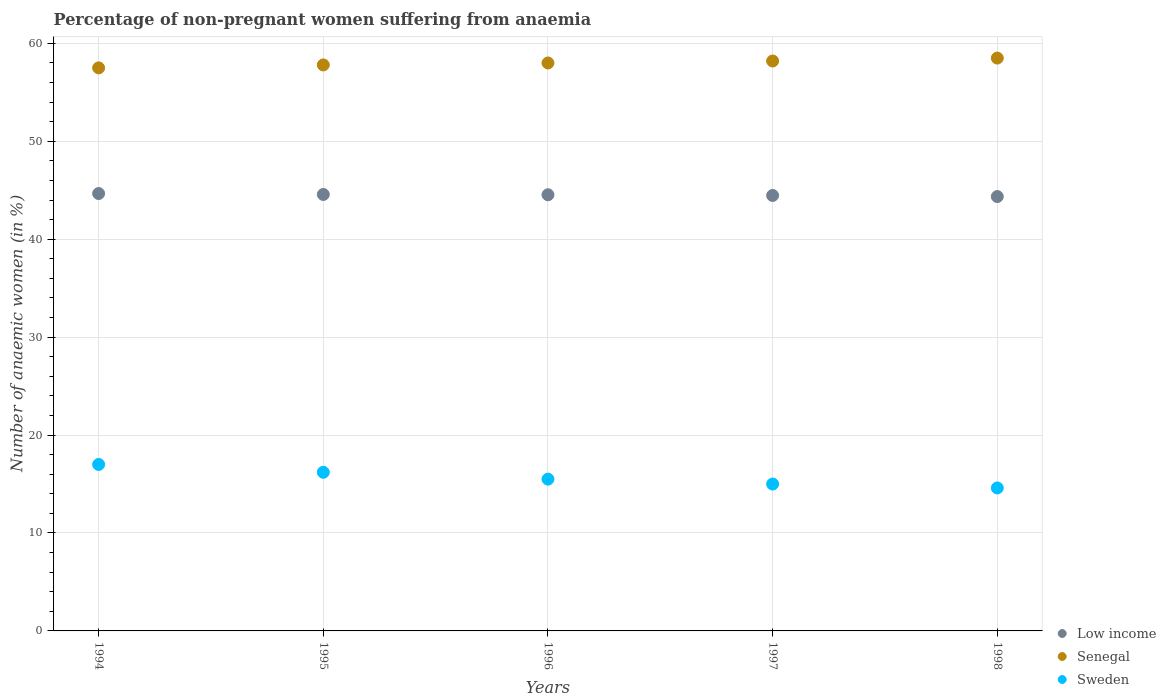How many different coloured dotlines are there?
Your response must be concise. 3. Is the number of dotlines equal to the number of legend labels?
Provide a succinct answer. Yes. What is the percentage of non-pregnant women suffering from anaemia in Low income in 1994?
Keep it short and to the point. 44.67. Across all years, what is the maximum percentage of non-pregnant women suffering from anaemia in Sweden?
Offer a terse response. 17. Across all years, what is the minimum percentage of non-pregnant women suffering from anaemia in Senegal?
Your answer should be very brief. 57.5. In which year was the percentage of non-pregnant women suffering from anaemia in Senegal maximum?
Your answer should be very brief. 1998. What is the total percentage of non-pregnant women suffering from anaemia in Sweden in the graph?
Provide a short and direct response. 78.3. What is the difference between the percentage of non-pregnant women suffering from anaemia in Sweden in 1995 and that in 1996?
Offer a very short reply. 0.7. What is the difference between the percentage of non-pregnant women suffering from anaemia in Senegal in 1994 and the percentage of non-pregnant women suffering from anaemia in Sweden in 1997?
Your answer should be very brief. 42.5. What is the average percentage of non-pregnant women suffering from anaemia in Senegal per year?
Give a very brief answer. 58. In the year 1998, what is the difference between the percentage of non-pregnant women suffering from anaemia in Low income and percentage of non-pregnant women suffering from anaemia in Sweden?
Provide a succinct answer. 29.76. What is the ratio of the percentage of non-pregnant women suffering from anaemia in Sweden in 1995 to that in 1998?
Your answer should be very brief. 1.11. Is the percentage of non-pregnant women suffering from anaemia in Sweden in 1996 less than that in 1997?
Provide a short and direct response. No. Is the difference between the percentage of non-pregnant women suffering from anaemia in Low income in 1994 and 1998 greater than the difference between the percentage of non-pregnant women suffering from anaemia in Sweden in 1994 and 1998?
Offer a terse response. No. What is the difference between the highest and the second highest percentage of non-pregnant women suffering from anaemia in Sweden?
Keep it short and to the point. 0.8. What is the difference between the highest and the lowest percentage of non-pregnant women suffering from anaemia in Low income?
Offer a terse response. 0.31. Is the sum of the percentage of non-pregnant women suffering from anaemia in Sweden in 1994 and 1996 greater than the maximum percentage of non-pregnant women suffering from anaemia in Senegal across all years?
Offer a terse response. No. Is the percentage of non-pregnant women suffering from anaemia in Low income strictly greater than the percentage of non-pregnant women suffering from anaemia in Sweden over the years?
Provide a short and direct response. Yes. Is the percentage of non-pregnant women suffering from anaemia in Senegal strictly less than the percentage of non-pregnant women suffering from anaemia in Sweden over the years?
Make the answer very short. No. How many dotlines are there?
Give a very brief answer. 3. How many years are there in the graph?
Ensure brevity in your answer.  5. What is the difference between two consecutive major ticks on the Y-axis?
Make the answer very short. 10. Where does the legend appear in the graph?
Keep it short and to the point. Bottom right. How are the legend labels stacked?
Give a very brief answer. Vertical. What is the title of the graph?
Give a very brief answer. Percentage of non-pregnant women suffering from anaemia. Does "Netherlands" appear as one of the legend labels in the graph?
Offer a terse response. No. What is the label or title of the X-axis?
Your response must be concise. Years. What is the label or title of the Y-axis?
Keep it short and to the point. Number of anaemic women (in %). What is the Number of anaemic women (in %) of Low income in 1994?
Provide a succinct answer. 44.67. What is the Number of anaemic women (in %) in Senegal in 1994?
Give a very brief answer. 57.5. What is the Number of anaemic women (in %) of Sweden in 1994?
Provide a succinct answer. 17. What is the Number of anaemic women (in %) of Low income in 1995?
Offer a very short reply. 44.57. What is the Number of anaemic women (in %) of Senegal in 1995?
Provide a succinct answer. 57.8. What is the Number of anaemic women (in %) of Low income in 1996?
Make the answer very short. 44.54. What is the Number of anaemic women (in %) in Sweden in 1996?
Provide a short and direct response. 15.5. What is the Number of anaemic women (in %) of Low income in 1997?
Your answer should be very brief. 44.47. What is the Number of anaemic women (in %) in Senegal in 1997?
Keep it short and to the point. 58.2. What is the Number of anaemic women (in %) of Sweden in 1997?
Provide a short and direct response. 15. What is the Number of anaemic women (in %) of Low income in 1998?
Provide a short and direct response. 44.36. What is the Number of anaemic women (in %) in Senegal in 1998?
Give a very brief answer. 58.5. What is the Number of anaemic women (in %) of Sweden in 1998?
Give a very brief answer. 14.6. Across all years, what is the maximum Number of anaemic women (in %) of Low income?
Your answer should be very brief. 44.67. Across all years, what is the maximum Number of anaemic women (in %) of Senegal?
Provide a short and direct response. 58.5. Across all years, what is the minimum Number of anaemic women (in %) in Low income?
Your response must be concise. 44.36. Across all years, what is the minimum Number of anaemic women (in %) of Senegal?
Keep it short and to the point. 57.5. Across all years, what is the minimum Number of anaemic women (in %) in Sweden?
Your answer should be very brief. 14.6. What is the total Number of anaemic women (in %) of Low income in the graph?
Make the answer very short. 222.61. What is the total Number of anaemic women (in %) in Senegal in the graph?
Offer a terse response. 290. What is the total Number of anaemic women (in %) in Sweden in the graph?
Your answer should be very brief. 78.3. What is the difference between the Number of anaemic women (in %) in Low income in 1994 and that in 1995?
Offer a terse response. 0.1. What is the difference between the Number of anaemic women (in %) of Low income in 1994 and that in 1996?
Give a very brief answer. 0.12. What is the difference between the Number of anaemic women (in %) in Senegal in 1994 and that in 1996?
Your answer should be very brief. -0.5. What is the difference between the Number of anaemic women (in %) of Sweden in 1994 and that in 1996?
Ensure brevity in your answer.  1.5. What is the difference between the Number of anaemic women (in %) of Low income in 1994 and that in 1997?
Your answer should be compact. 0.2. What is the difference between the Number of anaemic women (in %) in Sweden in 1994 and that in 1997?
Your answer should be compact. 2. What is the difference between the Number of anaemic women (in %) in Low income in 1994 and that in 1998?
Ensure brevity in your answer.  0.31. What is the difference between the Number of anaemic women (in %) of Sweden in 1994 and that in 1998?
Provide a short and direct response. 2.4. What is the difference between the Number of anaemic women (in %) in Low income in 1995 and that in 1996?
Offer a very short reply. 0.03. What is the difference between the Number of anaemic women (in %) of Low income in 1995 and that in 1997?
Offer a very short reply. 0.1. What is the difference between the Number of anaemic women (in %) in Senegal in 1995 and that in 1997?
Your answer should be very brief. -0.4. What is the difference between the Number of anaemic women (in %) in Low income in 1995 and that in 1998?
Your answer should be compact. 0.21. What is the difference between the Number of anaemic women (in %) of Senegal in 1995 and that in 1998?
Your answer should be compact. -0.7. What is the difference between the Number of anaemic women (in %) of Sweden in 1995 and that in 1998?
Make the answer very short. 1.6. What is the difference between the Number of anaemic women (in %) of Low income in 1996 and that in 1997?
Ensure brevity in your answer.  0.07. What is the difference between the Number of anaemic women (in %) in Senegal in 1996 and that in 1997?
Keep it short and to the point. -0.2. What is the difference between the Number of anaemic women (in %) of Sweden in 1996 and that in 1997?
Provide a succinct answer. 0.5. What is the difference between the Number of anaemic women (in %) of Low income in 1996 and that in 1998?
Give a very brief answer. 0.18. What is the difference between the Number of anaemic women (in %) of Senegal in 1996 and that in 1998?
Make the answer very short. -0.5. What is the difference between the Number of anaemic women (in %) in Low income in 1997 and that in 1998?
Give a very brief answer. 0.11. What is the difference between the Number of anaemic women (in %) in Senegal in 1997 and that in 1998?
Provide a short and direct response. -0.3. What is the difference between the Number of anaemic women (in %) of Sweden in 1997 and that in 1998?
Give a very brief answer. 0.4. What is the difference between the Number of anaemic women (in %) in Low income in 1994 and the Number of anaemic women (in %) in Senegal in 1995?
Offer a very short reply. -13.13. What is the difference between the Number of anaemic women (in %) in Low income in 1994 and the Number of anaemic women (in %) in Sweden in 1995?
Ensure brevity in your answer.  28.47. What is the difference between the Number of anaemic women (in %) of Senegal in 1994 and the Number of anaemic women (in %) of Sweden in 1995?
Your answer should be compact. 41.3. What is the difference between the Number of anaemic women (in %) in Low income in 1994 and the Number of anaemic women (in %) in Senegal in 1996?
Your answer should be compact. -13.33. What is the difference between the Number of anaemic women (in %) of Low income in 1994 and the Number of anaemic women (in %) of Sweden in 1996?
Give a very brief answer. 29.17. What is the difference between the Number of anaemic women (in %) of Low income in 1994 and the Number of anaemic women (in %) of Senegal in 1997?
Provide a succinct answer. -13.53. What is the difference between the Number of anaemic women (in %) of Low income in 1994 and the Number of anaemic women (in %) of Sweden in 1997?
Provide a succinct answer. 29.67. What is the difference between the Number of anaemic women (in %) of Senegal in 1994 and the Number of anaemic women (in %) of Sweden in 1997?
Provide a succinct answer. 42.5. What is the difference between the Number of anaemic women (in %) in Low income in 1994 and the Number of anaemic women (in %) in Senegal in 1998?
Ensure brevity in your answer.  -13.83. What is the difference between the Number of anaemic women (in %) in Low income in 1994 and the Number of anaemic women (in %) in Sweden in 1998?
Offer a very short reply. 30.07. What is the difference between the Number of anaemic women (in %) of Senegal in 1994 and the Number of anaemic women (in %) of Sweden in 1998?
Provide a short and direct response. 42.9. What is the difference between the Number of anaemic women (in %) in Low income in 1995 and the Number of anaemic women (in %) in Senegal in 1996?
Your answer should be compact. -13.43. What is the difference between the Number of anaemic women (in %) in Low income in 1995 and the Number of anaemic women (in %) in Sweden in 1996?
Offer a very short reply. 29.07. What is the difference between the Number of anaemic women (in %) in Senegal in 1995 and the Number of anaemic women (in %) in Sweden in 1996?
Your response must be concise. 42.3. What is the difference between the Number of anaemic women (in %) in Low income in 1995 and the Number of anaemic women (in %) in Senegal in 1997?
Your response must be concise. -13.63. What is the difference between the Number of anaemic women (in %) of Low income in 1995 and the Number of anaemic women (in %) of Sweden in 1997?
Offer a very short reply. 29.57. What is the difference between the Number of anaemic women (in %) of Senegal in 1995 and the Number of anaemic women (in %) of Sweden in 1997?
Ensure brevity in your answer.  42.8. What is the difference between the Number of anaemic women (in %) of Low income in 1995 and the Number of anaemic women (in %) of Senegal in 1998?
Keep it short and to the point. -13.93. What is the difference between the Number of anaemic women (in %) of Low income in 1995 and the Number of anaemic women (in %) of Sweden in 1998?
Give a very brief answer. 29.97. What is the difference between the Number of anaemic women (in %) in Senegal in 1995 and the Number of anaemic women (in %) in Sweden in 1998?
Give a very brief answer. 43.2. What is the difference between the Number of anaemic women (in %) in Low income in 1996 and the Number of anaemic women (in %) in Senegal in 1997?
Provide a succinct answer. -13.66. What is the difference between the Number of anaemic women (in %) of Low income in 1996 and the Number of anaemic women (in %) of Sweden in 1997?
Make the answer very short. 29.54. What is the difference between the Number of anaemic women (in %) in Senegal in 1996 and the Number of anaemic women (in %) in Sweden in 1997?
Give a very brief answer. 43. What is the difference between the Number of anaemic women (in %) of Low income in 1996 and the Number of anaemic women (in %) of Senegal in 1998?
Offer a terse response. -13.96. What is the difference between the Number of anaemic women (in %) in Low income in 1996 and the Number of anaemic women (in %) in Sweden in 1998?
Give a very brief answer. 29.94. What is the difference between the Number of anaemic women (in %) in Senegal in 1996 and the Number of anaemic women (in %) in Sweden in 1998?
Give a very brief answer. 43.4. What is the difference between the Number of anaemic women (in %) of Low income in 1997 and the Number of anaemic women (in %) of Senegal in 1998?
Ensure brevity in your answer.  -14.03. What is the difference between the Number of anaemic women (in %) of Low income in 1997 and the Number of anaemic women (in %) of Sweden in 1998?
Give a very brief answer. 29.87. What is the difference between the Number of anaemic women (in %) of Senegal in 1997 and the Number of anaemic women (in %) of Sweden in 1998?
Provide a succinct answer. 43.6. What is the average Number of anaemic women (in %) in Low income per year?
Offer a very short reply. 44.52. What is the average Number of anaemic women (in %) of Senegal per year?
Offer a very short reply. 58. What is the average Number of anaemic women (in %) of Sweden per year?
Offer a very short reply. 15.66. In the year 1994, what is the difference between the Number of anaemic women (in %) of Low income and Number of anaemic women (in %) of Senegal?
Make the answer very short. -12.83. In the year 1994, what is the difference between the Number of anaemic women (in %) in Low income and Number of anaemic women (in %) in Sweden?
Provide a succinct answer. 27.67. In the year 1994, what is the difference between the Number of anaemic women (in %) in Senegal and Number of anaemic women (in %) in Sweden?
Ensure brevity in your answer.  40.5. In the year 1995, what is the difference between the Number of anaemic women (in %) in Low income and Number of anaemic women (in %) in Senegal?
Your answer should be very brief. -13.23. In the year 1995, what is the difference between the Number of anaemic women (in %) in Low income and Number of anaemic women (in %) in Sweden?
Offer a very short reply. 28.37. In the year 1995, what is the difference between the Number of anaemic women (in %) of Senegal and Number of anaemic women (in %) of Sweden?
Keep it short and to the point. 41.6. In the year 1996, what is the difference between the Number of anaemic women (in %) in Low income and Number of anaemic women (in %) in Senegal?
Offer a very short reply. -13.46. In the year 1996, what is the difference between the Number of anaemic women (in %) in Low income and Number of anaemic women (in %) in Sweden?
Your answer should be compact. 29.04. In the year 1996, what is the difference between the Number of anaemic women (in %) in Senegal and Number of anaemic women (in %) in Sweden?
Give a very brief answer. 42.5. In the year 1997, what is the difference between the Number of anaemic women (in %) in Low income and Number of anaemic women (in %) in Senegal?
Provide a short and direct response. -13.73. In the year 1997, what is the difference between the Number of anaemic women (in %) in Low income and Number of anaemic women (in %) in Sweden?
Make the answer very short. 29.47. In the year 1997, what is the difference between the Number of anaemic women (in %) in Senegal and Number of anaemic women (in %) in Sweden?
Keep it short and to the point. 43.2. In the year 1998, what is the difference between the Number of anaemic women (in %) in Low income and Number of anaemic women (in %) in Senegal?
Your response must be concise. -14.14. In the year 1998, what is the difference between the Number of anaemic women (in %) of Low income and Number of anaemic women (in %) of Sweden?
Provide a short and direct response. 29.76. In the year 1998, what is the difference between the Number of anaemic women (in %) in Senegal and Number of anaemic women (in %) in Sweden?
Offer a very short reply. 43.9. What is the ratio of the Number of anaemic women (in %) of Senegal in 1994 to that in 1995?
Keep it short and to the point. 0.99. What is the ratio of the Number of anaemic women (in %) in Sweden in 1994 to that in 1995?
Ensure brevity in your answer.  1.05. What is the ratio of the Number of anaemic women (in %) in Sweden in 1994 to that in 1996?
Give a very brief answer. 1.1. What is the ratio of the Number of anaemic women (in %) of Low income in 1994 to that in 1997?
Offer a terse response. 1. What is the ratio of the Number of anaemic women (in %) of Sweden in 1994 to that in 1997?
Ensure brevity in your answer.  1.13. What is the ratio of the Number of anaemic women (in %) in Low income in 1994 to that in 1998?
Offer a very short reply. 1.01. What is the ratio of the Number of anaemic women (in %) in Senegal in 1994 to that in 1998?
Ensure brevity in your answer.  0.98. What is the ratio of the Number of anaemic women (in %) of Sweden in 1994 to that in 1998?
Offer a very short reply. 1.16. What is the ratio of the Number of anaemic women (in %) in Low income in 1995 to that in 1996?
Your answer should be compact. 1. What is the ratio of the Number of anaemic women (in %) of Senegal in 1995 to that in 1996?
Provide a succinct answer. 1. What is the ratio of the Number of anaemic women (in %) in Sweden in 1995 to that in 1996?
Provide a short and direct response. 1.05. What is the ratio of the Number of anaemic women (in %) of Low income in 1995 to that in 1997?
Your answer should be very brief. 1. What is the ratio of the Number of anaemic women (in %) in Low income in 1995 to that in 1998?
Ensure brevity in your answer.  1. What is the ratio of the Number of anaemic women (in %) in Sweden in 1995 to that in 1998?
Provide a succinct answer. 1.11. What is the ratio of the Number of anaemic women (in %) in Low income in 1996 to that in 1997?
Keep it short and to the point. 1. What is the ratio of the Number of anaemic women (in %) in Senegal in 1996 to that in 1997?
Ensure brevity in your answer.  1. What is the ratio of the Number of anaemic women (in %) of Senegal in 1996 to that in 1998?
Provide a succinct answer. 0.99. What is the ratio of the Number of anaemic women (in %) of Sweden in 1996 to that in 1998?
Make the answer very short. 1.06. What is the ratio of the Number of anaemic women (in %) in Sweden in 1997 to that in 1998?
Keep it short and to the point. 1.03. What is the difference between the highest and the second highest Number of anaemic women (in %) of Low income?
Your answer should be compact. 0.1. What is the difference between the highest and the second highest Number of anaemic women (in %) in Senegal?
Offer a terse response. 0.3. What is the difference between the highest and the lowest Number of anaemic women (in %) of Low income?
Your answer should be compact. 0.31. 